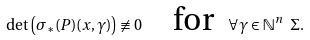Convert formula to latex. <formula><loc_0><loc_0><loc_500><loc_500>\det \left ( \sigma _ { * } ( P ) ( x , \gamma ) \right ) \not \equiv 0 \quad \text {for \ } \forall \gamma \in \mathbb { N } ^ { n } \ \Sigma .</formula> 